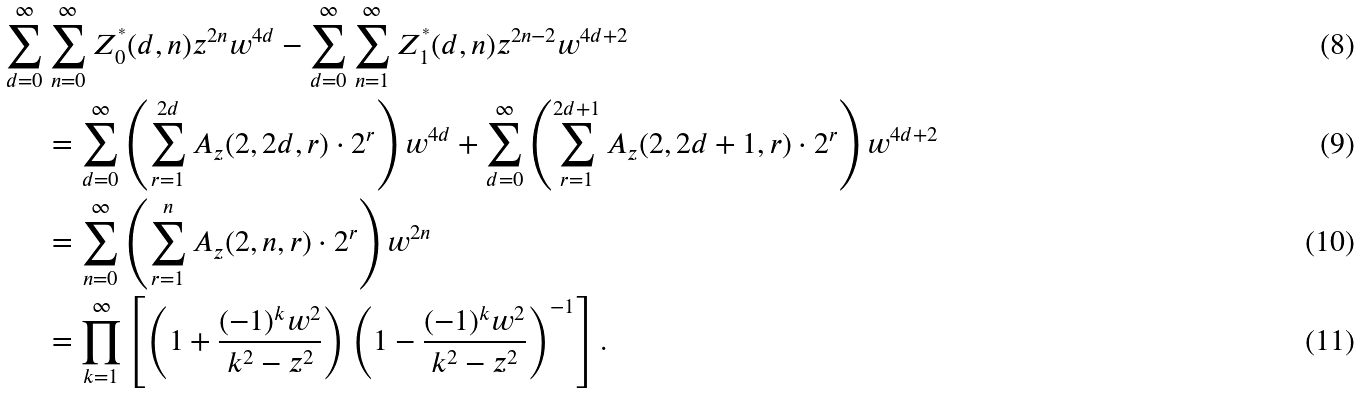<formula> <loc_0><loc_0><loc_500><loc_500>\sum _ { d = 0 } ^ { \infty } & \sum _ { n = 0 } ^ { \infty } Z ^ { ^ { * } } _ { 0 } ( d , n ) z ^ { 2 n } w ^ { 4 d } - \sum _ { d = 0 } ^ { \infty } \sum _ { n = 1 } ^ { \infty } Z ^ { ^ { * } } _ { 1 } ( d , n ) z ^ { 2 n - 2 } w ^ { 4 d + 2 } \\ & = \sum _ { d = 0 } ^ { \infty } \left ( \sum _ { r = 1 } ^ { 2 d } A _ { z } ( 2 , 2 d , r ) \cdot 2 ^ { r } \right ) w ^ { 4 d } + \sum _ { d = 0 } ^ { \infty } \left ( \sum _ { r = 1 } ^ { 2 d + 1 } A _ { z } ( 2 , 2 d + 1 , r ) \cdot 2 ^ { r } \right ) w ^ { 4 d + 2 } \\ & = \sum _ { n = 0 } ^ { \infty } \left ( \sum _ { r = 1 } ^ { n } A _ { z } ( 2 , n , r ) \cdot 2 ^ { r } \right ) w ^ { 2 n } \\ & = \prod _ { k = 1 } ^ { \infty } \left [ \left ( 1 + \frac { ( - 1 ) ^ { k } w ^ { 2 } } { k ^ { 2 } - z ^ { 2 } } \right ) \left ( 1 - \frac { ( - 1 ) ^ { k } w ^ { 2 } } { k ^ { 2 } - z ^ { 2 } } \right ) ^ { - 1 } \right ] .</formula> 